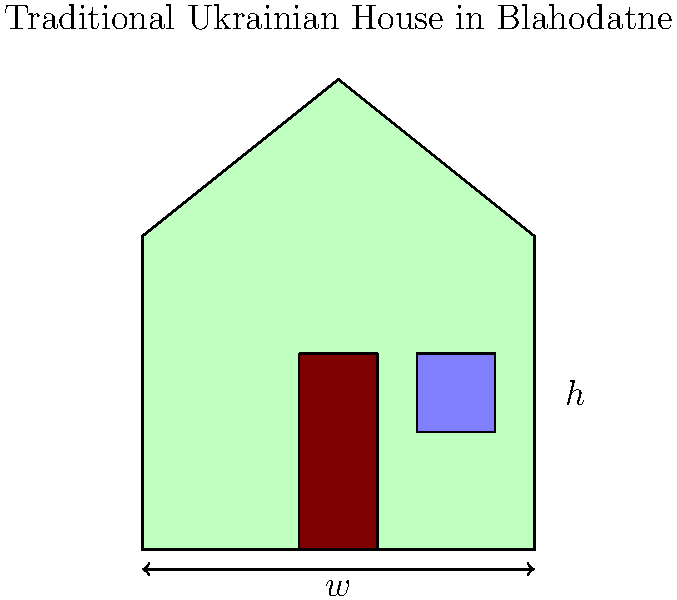In traditional Ukrainian houses in Blahodatne, the ratio of height ($h$) to width ($w$) is often approximately the golden ratio. If the width of a house is 8 meters, what should its height be to maintain this proportion? Round your answer to the nearest decimeter. To solve this problem, we'll follow these steps:

1. Recall the golden ratio: $\phi = \frac{1 + \sqrt{5}}{2} \approx 1.618$

2. In our case, the ratio of height to width should be approximately equal to the golden ratio:

   $\frac{h}{w} \approx \phi$

3. We know the width ($w$) is 8 meters, so we can set up the equation:

   $\frac{h}{8} \approx 1.618$

4. To find $h$, multiply both sides by 8:

   $h \approx 8 * 1.618 = 12.944$ meters

5. Rounding to the nearest decimeter (0.1 meter):

   $h \approx 12.9$ meters

Therefore, for a traditional Ukrainian house in Blahodatne with a width of 8 meters, the height should be approximately 12.9 meters to maintain the golden ratio proportion.
Answer: 12.9 meters 